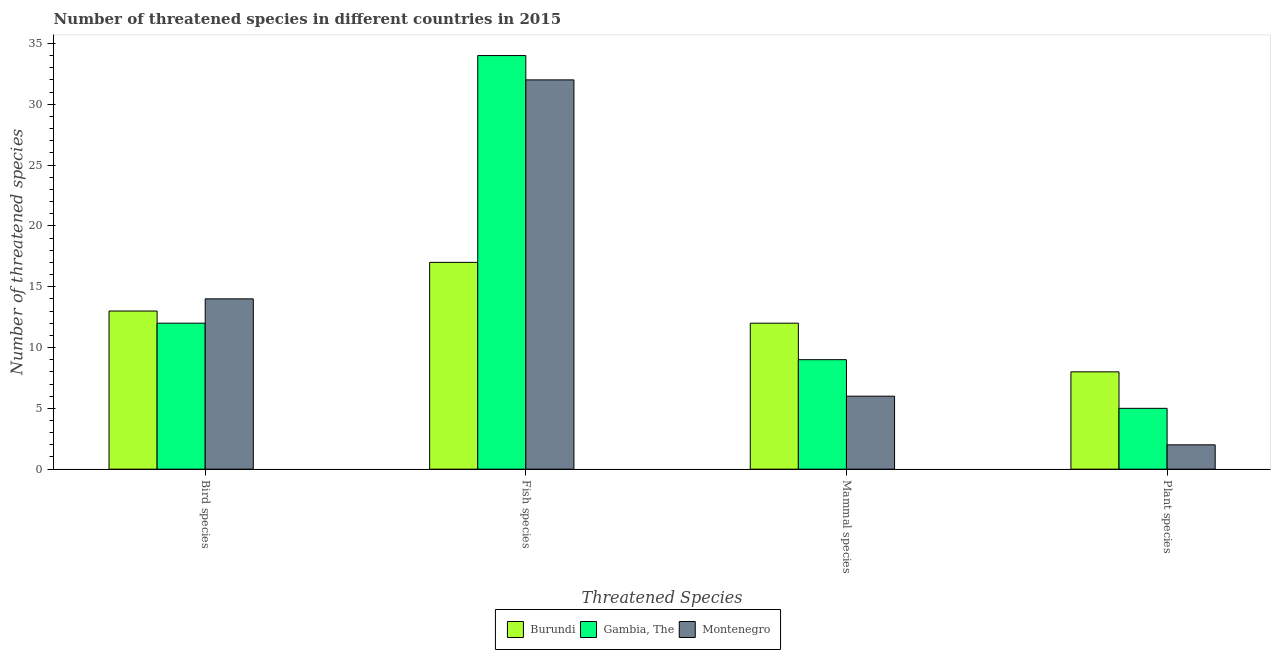How many different coloured bars are there?
Make the answer very short. 3. How many groups of bars are there?
Your answer should be compact. 4. How many bars are there on the 4th tick from the left?
Offer a very short reply. 3. How many bars are there on the 1st tick from the right?
Your response must be concise. 3. What is the label of the 4th group of bars from the left?
Offer a terse response. Plant species. What is the number of threatened plant species in Burundi?
Your response must be concise. 8. Across all countries, what is the maximum number of threatened mammal species?
Your answer should be compact. 12. Across all countries, what is the minimum number of threatened fish species?
Your response must be concise. 17. In which country was the number of threatened plant species maximum?
Your response must be concise. Burundi. In which country was the number of threatened plant species minimum?
Your answer should be very brief. Montenegro. What is the total number of threatened bird species in the graph?
Offer a terse response. 39. What is the difference between the number of threatened plant species in Montenegro and that in Burundi?
Keep it short and to the point. -6. What is the difference between the number of threatened fish species in Burundi and the number of threatened bird species in Montenegro?
Offer a terse response. 3. What is the average number of threatened fish species per country?
Give a very brief answer. 27.67. What is the difference between the number of threatened plant species and number of threatened bird species in Gambia, The?
Your answer should be very brief. -7. What is the ratio of the number of threatened fish species in Montenegro to that in Gambia, The?
Offer a very short reply. 0.94. Is the number of threatened mammal species in Gambia, The less than that in Burundi?
Offer a very short reply. Yes. What is the difference between the highest and the second highest number of threatened mammal species?
Ensure brevity in your answer.  3. What is the difference between the highest and the lowest number of threatened bird species?
Provide a short and direct response. 2. In how many countries, is the number of threatened plant species greater than the average number of threatened plant species taken over all countries?
Give a very brief answer. 1. Is the sum of the number of threatened fish species in Montenegro and Gambia, The greater than the maximum number of threatened plant species across all countries?
Your answer should be very brief. Yes. Is it the case that in every country, the sum of the number of threatened mammal species and number of threatened plant species is greater than the sum of number of threatened bird species and number of threatened fish species?
Your answer should be very brief. No. What does the 2nd bar from the left in Mammal species represents?
Offer a terse response. Gambia, The. What does the 1st bar from the right in Mammal species represents?
Your response must be concise. Montenegro. Is it the case that in every country, the sum of the number of threatened bird species and number of threatened fish species is greater than the number of threatened mammal species?
Give a very brief answer. Yes. How many bars are there?
Your answer should be compact. 12. Are all the bars in the graph horizontal?
Your response must be concise. No. How many countries are there in the graph?
Your response must be concise. 3. Does the graph contain any zero values?
Offer a very short reply. No. Does the graph contain grids?
Keep it short and to the point. No. Where does the legend appear in the graph?
Ensure brevity in your answer.  Bottom center. What is the title of the graph?
Keep it short and to the point. Number of threatened species in different countries in 2015. What is the label or title of the X-axis?
Offer a very short reply. Threatened Species. What is the label or title of the Y-axis?
Offer a very short reply. Number of threatened species. What is the Number of threatened species in Burundi in Bird species?
Give a very brief answer. 13. What is the Number of threatened species in Gambia, The in Bird species?
Offer a terse response. 12. What is the Number of threatened species of Montenegro in Bird species?
Keep it short and to the point. 14. What is the Number of threatened species of Montenegro in Fish species?
Your answer should be compact. 32. What is the Number of threatened species in Burundi in Mammal species?
Make the answer very short. 12. What is the Number of threatened species of Montenegro in Plant species?
Keep it short and to the point. 2. Across all Threatened Species, what is the maximum Number of threatened species in Burundi?
Provide a short and direct response. 17. Across all Threatened Species, what is the maximum Number of threatened species of Gambia, The?
Your answer should be compact. 34. Across all Threatened Species, what is the minimum Number of threatened species of Burundi?
Give a very brief answer. 8. Across all Threatened Species, what is the minimum Number of threatened species of Gambia, The?
Give a very brief answer. 5. Across all Threatened Species, what is the minimum Number of threatened species of Montenegro?
Offer a very short reply. 2. What is the total Number of threatened species in Montenegro in the graph?
Provide a short and direct response. 54. What is the difference between the Number of threatened species in Gambia, The in Bird species and that in Fish species?
Your response must be concise. -22. What is the difference between the Number of threatened species of Gambia, The in Bird species and that in Mammal species?
Provide a short and direct response. 3. What is the difference between the Number of threatened species of Montenegro in Bird species and that in Mammal species?
Provide a succinct answer. 8. What is the difference between the Number of threatened species of Gambia, The in Fish species and that in Mammal species?
Your response must be concise. 25. What is the difference between the Number of threatened species in Burundi in Fish species and that in Plant species?
Provide a short and direct response. 9. What is the difference between the Number of threatened species in Gambia, The in Fish species and that in Plant species?
Your answer should be very brief. 29. What is the difference between the Number of threatened species in Burundi in Mammal species and that in Plant species?
Ensure brevity in your answer.  4. What is the difference between the Number of threatened species in Montenegro in Mammal species and that in Plant species?
Ensure brevity in your answer.  4. What is the difference between the Number of threatened species of Burundi in Bird species and the Number of threatened species of Gambia, The in Fish species?
Make the answer very short. -21. What is the difference between the Number of threatened species in Burundi in Bird species and the Number of threatened species in Montenegro in Fish species?
Offer a terse response. -19. What is the difference between the Number of threatened species in Gambia, The in Bird species and the Number of threatened species in Montenegro in Fish species?
Provide a short and direct response. -20. What is the difference between the Number of threatened species in Burundi in Bird species and the Number of threatened species in Gambia, The in Plant species?
Give a very brief answer. 8. What is the difference between the Number of threatened species of Burundi in Bird species and the Number of threatened species of Montenegro in Plant species?
Your response must be concise. 11. What is the difference between the Number of threatened species in Gambia, The in Bird species and the Number of threatened species in Montenegro in Plant species?
Offer a very short reply. 10. What is the difference between the Number of threatened species in Burundi in Fish species and the Number of threatened species in Gambia, The in Mammal species?
Make the answer very short. 8. What is the difference between the Number of threatened species of Burundi in Fish species and the Number of threatened species of Montenegro in Mammal species?
Your answer should be very brief. 11. What is the difference between the Number of threatened species of Gambia, The in Fish species and the Number of threatened species of Montenegro in Mammal species?
Ensure brevity in your answer.  28. What is the difference between the Number of threatened species of Gambia, The in Fish species and the Number of threatened species of Montenegro in Plant species?
Keep it short and to the point. 32. What is the difference between the Number of threatened species of Burundi in Mammal species and the Number of threatened species of Gambia, The in Plant species?
Give a very brief answer. 7. What is the average Number of threatened species in Burundi per Threatened Species?
Provide a succinct answer. 12.5. What is the difference between the Number of threatened species of Burundi and Number of threatened species of Montenegro in Bird species?
Your response must be concise. -1. What is the difference between the Number of threatened species in Gambia, The and Number of threatened species in Montenegro in Bird species?
Give a very brief answer. -2. What is the difference between the Number of threatened species in Gambia, The and Number of threatened species in Montenegro in Mammal species?
Provide a short and direct response. 3. What is the difference between the Number of threatened species of Burundi and Number of threatened species of Montenegro in Plant species?
Your answer should be compact. 6. What is the ratio of the Number of threatened species of Burundi in Bird species to that in Fish species?
Your response must be concise. 0.76. What is the ratio of the Number of threatened species of Gambia, The in Bird species to that in Fish species?
Your response must be concise. 0.35. What is the ratio of the Number of threatened species of Montenegro in Bird species to that in Fish species?
Ensure brevity in your answer.  0.44. What is the ratio of the Number of threatened species of Burundi in Bird species to that in Mammal species?
Provide a short and direct response. 1.08. What is the ratio of the Number of threatened species of Gambia, The in Bird species to that in Mammal species?
Offer a very short reply. 1.33. What is the ratio of the Number of threatened species of Montenegro in Bird species to that in Mammal species?
Provide a short and direct response. 2.33. What is the ratio of the Number of threatened species of Burundi in Bird species to that in Plant species?
Keep it short and to the point. 1.62. What is the ratio of the Number of threatened species of Gambia, The in Bird species to that in Plant species?
Your answer should be very brief. 2.4. What is the ratio of the Number of threatened species in Montenegro in Bird species to that in Plant species?
Make the answer very short. 7. What is the ratio of the Number of threatened species in Burundi in Fish species to that in Mammal species?
Your answer should be very brief. 1.42. What is the ratio of the Number of threatened species in Gambia, The in Fish species to that in Mammal species?
Your answer should be very brief. 3.78. What is the ratio of the Number of threatened species of Montenegro in Fish species to that in Mammal species?
Your response must be concise. 5.33. What is the ratio of the Number of threatened species in Burundi in Fish species to that in Plant species?
Provide a short and direct response. 2.12. What is the ratio of the Number of threatened species of Montenegro in Fish species to that in Plant species?
Make the answer very short. 16. What is the ratio of the Number of threatened species in Gambia, The in Mammal species to that in Plant species?
Provide a succinct answer. 1.8. What is the ratio of the Number of threatened species of Montenegro in Mammal species to that in Plant species?
Provide a succinct answer. 3. What is the difference between the highest and the second highest Number of threatened species of Burundi?
Your answer should be very brief. 4. What is the difference between the highest and the second highest Number of threatened species of Gambia, The?
Provide a succinct answer. 22. What is the difference between the highest and the lowest Number of threatened species in Burundi?
Make the answer very short. 9. 